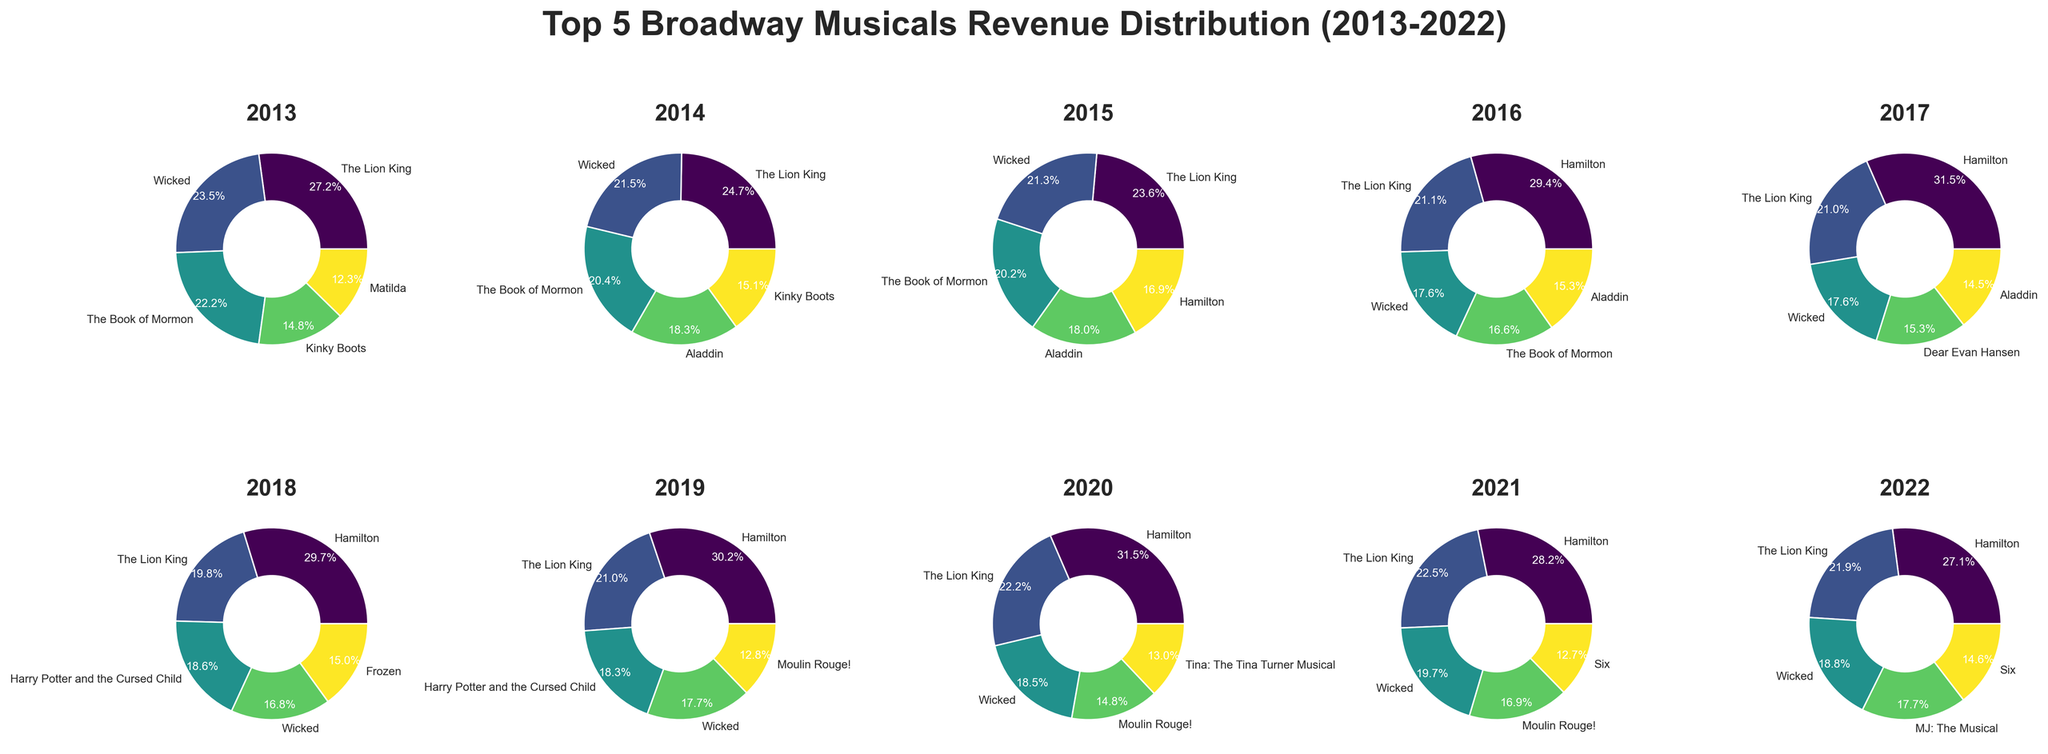What was the total revenue for 'Hamilton' in 2017 and 2018? From the subplots, locate the slices labeled "Hamilton" for the years 2017 and 2018. Sum the revenues provided in the pie chart labels or around the slices. For 2017, 'Hamilton' earned 165,000,000 and in 2018, it earned 168,000,000. Adding these together, we get 165,000,000 + 168,000,000 = 333,000,000.
Answer: 333,000,000 Which musical had the highest revenue in 2016? Identify the largest slice in the 2016 subplot. 'Hamilton' had the largest slice, and the label around it reads 150,000,000. Hence, 'Hamilton' had the highest revenue in 2016.
Answer: Hamilton In which year did 'The Lion King' have its lowest revenue, and what was the revenue amount? Look for the smallest slice labeled "The Lion King" across all the subplots. In 2020, 'The Lion King' had the smallest slice, and the label reads 60,000,000. Therefore, 2020 was the year with the lowest revenue for 'The Lion King' at 60,000,000.
Answer: 2020, 60,000,000 How did 'Wicked's revenue change from 2013 to 2014? Examine the slices labeled "Wicked" for the years 2013 and 2014. In 2013, 'Wicked' had a revenue of 95,000,000 and in 2014 it had a revenue of 100,000,000. Calculate the difference: 100,000,000 - 95,000,000 = 5,000,000, indicating an increase of 5,000,000.
Answer: It increased by 5,000,000 What percentage of total revenue did 'Dear Evan Hansen' contribute in 2017? Find 'Dear Evan Hansen' in the 2017 subplot and locate the percentage label on its slice. The label reads 80,000,000. Aggregate the revenue of all musicals in 2017, then calculate the percentage: Total for 2017 = (165,000,000 + 110,000,000 + 92,000,000 + 80,000,000 + 76,000,000) = 523,000,000. 80,000,000/523,000,000 = ~15.29%.
Answer: 15.29% Which musical appears most frequently in the top 5 list from 2013 to 2022? Identify the musical titles that appear most frequently across all subplots. 'The Lion King' and 'Wicked' appear consistently year after year. Tally their occurrences to find the most frequent one. 'The Lion King' appears 10 times, while 'Wicked' also appears 10 times.
Answer: The Lion King and Wicked (tie) In which year and for which musical did the revenue drop the most compared to the previous year? For each year, compare the revenue of each musical to its previous year's revenue. The noticeable drop should be identified in 'Hamilton' for 2020: from 165,000,000 in 2019 to 85,000,000 in 2020, a drop of 80,000,000.
Answer: 2020, Hamilton, 80,000,000 What is the average revenue of 'Frozen' over the years it appears in the charts? Identify the years 'Frozen' appears. 'Frozen' appears in 2018 with revenue of 85,000,000. Since it only appears once, the average revenue is the same as the single value present.
Answer: 85,000,000 